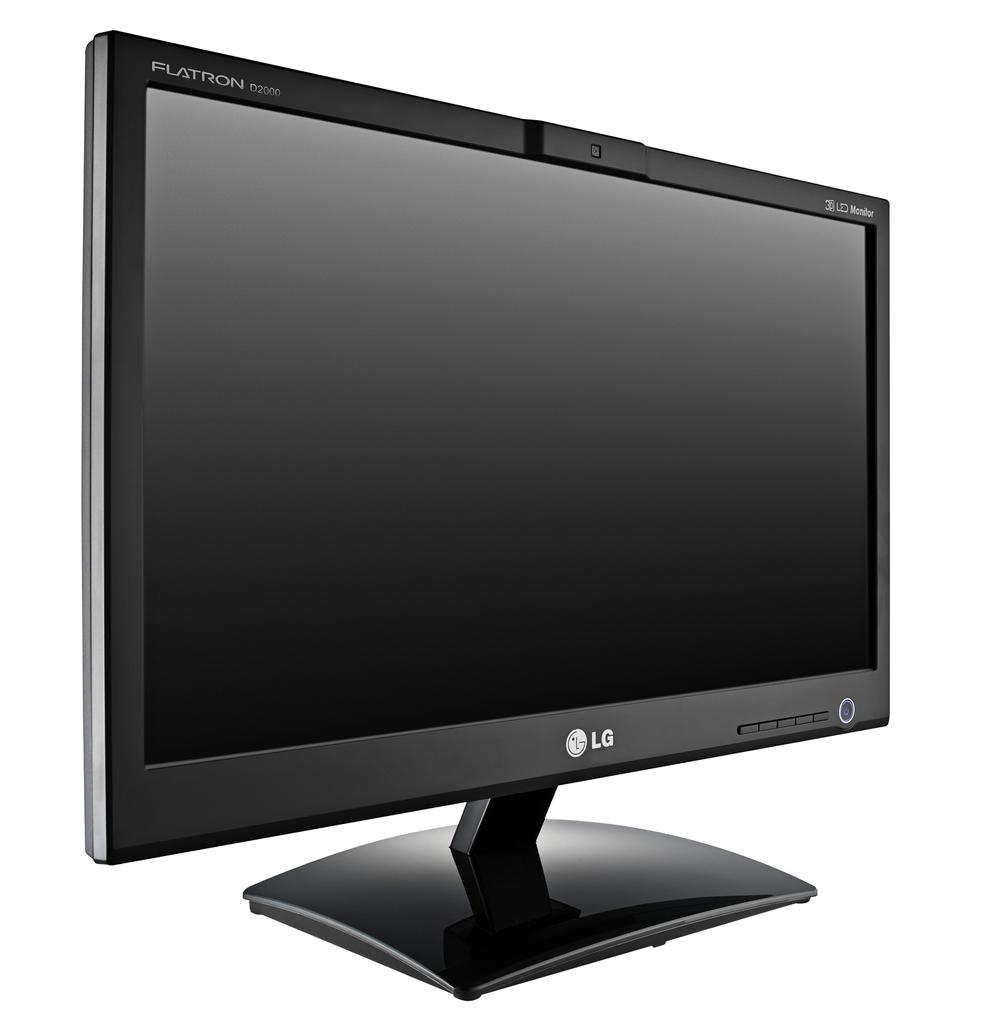<image>
Provide a brief description of the given image. An LG brand Flatron 3D LED TV monitor. 